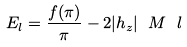<formula> <loc_0><loc_0><loc_500><loc_500>E _ { l } = \frac { f ( \pi ) } { \pi } - 2 | h _ { z } | \ M \ l</formula> 